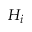Convert formula to latex. <formula><loc_0><loc_0><loc_500><loc_500>H _ { i }</formula> 